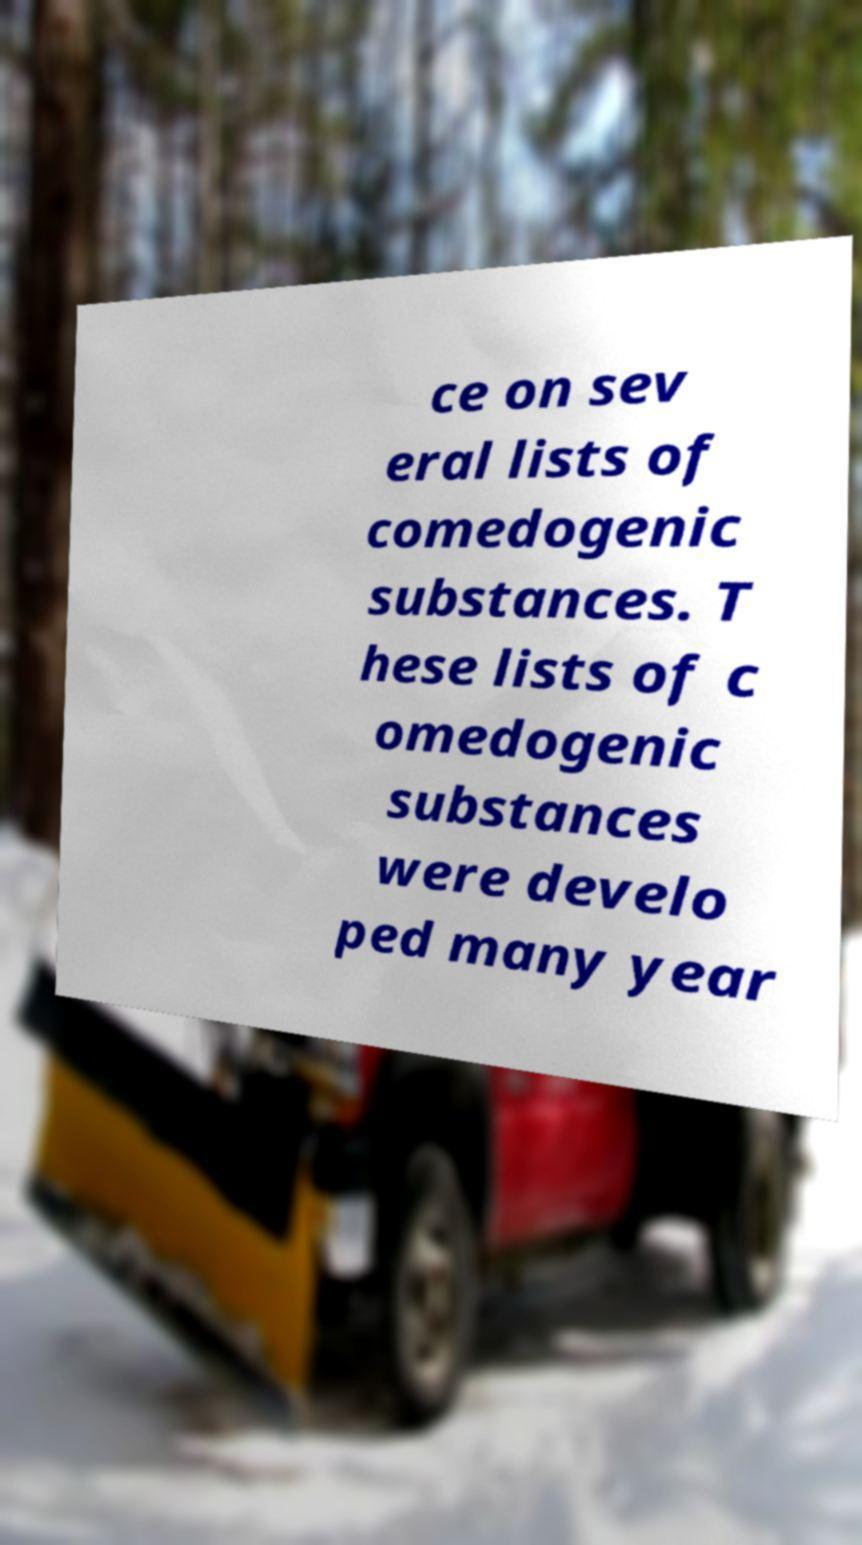For documentation purposes, I need the text within this image transcribed. Could you provide that? ce on sev eral lists of comedogenic substances. T hese lists of c omedogenic substances were develo ped many year 